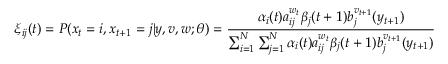Convert formula to latex. <formula><loc_0><loc_0><loc_500><loc_500>\xi _ { i j } ( t ) = P ( x _ { t } = i , x _ { t + 1 } = j | y , v , w ; \theta ) = { \frac { \alpha _ { i } ( t ) a _ { i j } ^ { w _ { t } } \beta _ { j } ( t + 1 ) b _ { j } ^ { v _ { t + 1 } } ( y _ { t + 1 } ) } { \sum _ { i = 1 } ^ { N } \sum _ { j = 1 } ^ { N } \alpha _ { i } ( t ) a _ { i j } ^ { w _ { t } } \beta _ { j } ( t + 1 ) b _ { j } ^ { v _ { t + 1 } } ( y _ { t + 1 } ) } }</formula> 